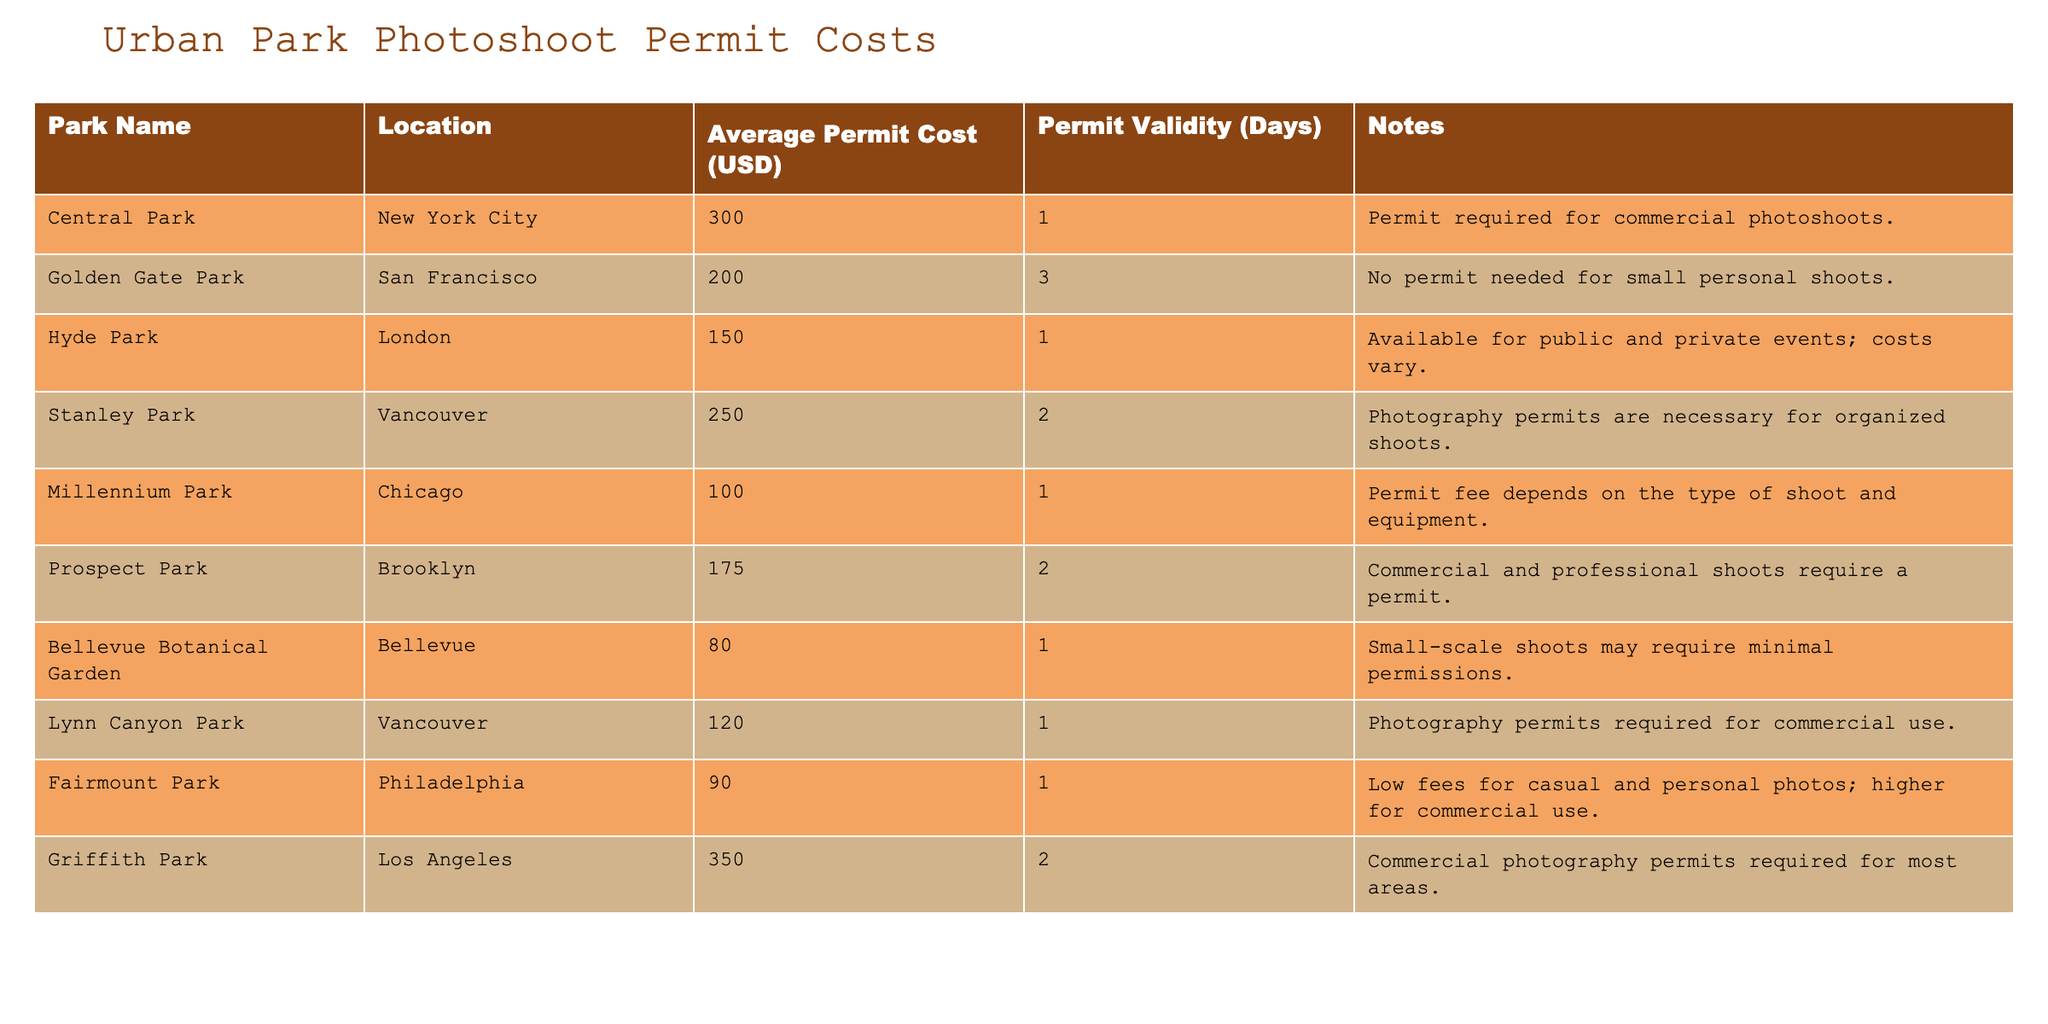What is the average permit cost for a photoshoot in Central Park? The table lists the average permit cost for Central Park as USD 300.
Answer: 300 How long is the permit validity at Golden Gate Park? According to the table, the permit validity at Golden Gate Park is 3 days.
Answer: 3 days Which park has the lowest average permit cost? From the table, Bellevue Botanical Garden has the lowest average permit cost at USD 80.
Answer: 80 Is a permit required for a commercial photoshoot in Lynn Canyon Park? The table states that photography permits are required for commercial use in Lynn Canyon Park, so the answer is yes.
Answer: Yes What is the total average permit cost for photoshoots in Stanley Park and Griffith Park? Stanley Park has an average permit cost of USD 250, and Griffith Park has USD 350. Adding these gives 250 + 350 = 600.
Answer: 600 Which parks do not require permits for small personal shoots? The table indicates that Golden Gate Park does not need a permit for small personal shoots, and Bellevue Botanical Garden may require minimal permissions. So, the answer is Golden Gate Park.
Answer: Golden Gate Park What is the median average permit cost among the parks listed? The average permit costs in ascending order are 80, 90, 100, 120, 150, 175, 200, 250, 300, 350, which totals 11 parks. The median cost is the 6th value, which is 175.
Answer: 175 How many parks have an average permit cost of more than USD 200? According to the table, the parks with an average permit cost over USD 200 are Central Park, Griffith Park, and Stanley Park, totaling 3 parks.
Answer: 3 Is the permit validity longer in Prospect Park than in Millennium Park? The table shows that Prospect Park has a permit validity of 2 days while Millennium Park has 1 day. Therefore, the validity in Prospect Park is longer.
Answer: Yes 